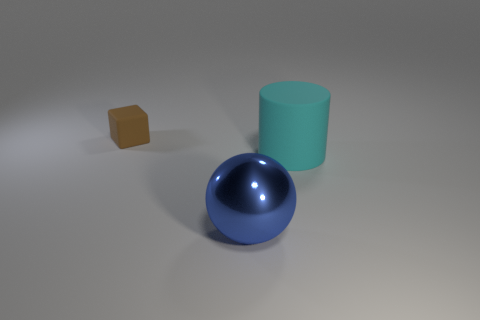Add 2 big things. How many objects exist? 5 Subtract all cylinders. How many objects are left? 2 Subtract all rubber cubes. Subtract all tiny matte cubes. How many objects are left? 1 Add 3 blue things. How many blue things are left? 4 Add 1 rubber cylinders. How many rubber cylinders exist? 2 Subtract 0 blue cubes. How many objects are left? 3 Subtract 1 spheres. How many spheres are left? 0 Subtract all purple spheres. Subtract all brown cylinders. How many spheres are left? 1 